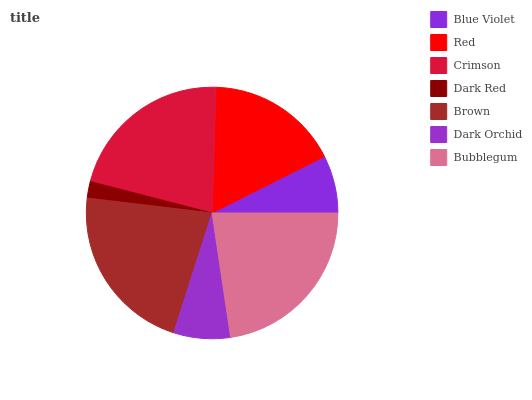Is Dark Red the minimum?
Answer yes or no. Yes. Is Bubblegum the maximum?
Answer yes or no. Yes. Is Red the minimum?
Answer yes or no. No. Is Red the maximum?
Answer yes or no. No. Is Red greater than Blue Violet?
Answer yes or no. Yes. Is Blue Violet less than Red?
Answer yes or no. Yes. Is Blue Violet greater than Red?
Answer yes or no. No. Is Red less than Blue Violet?
Answer yes or no. No. Is Red the high median?
Answer yes or no. Yes. Is Red the low median?
Answer yes or no. Yes. Is Bubblegum the high median?
Answer yes or no. No. Is Blue Violet the low median?
Answer yes or no. No. 